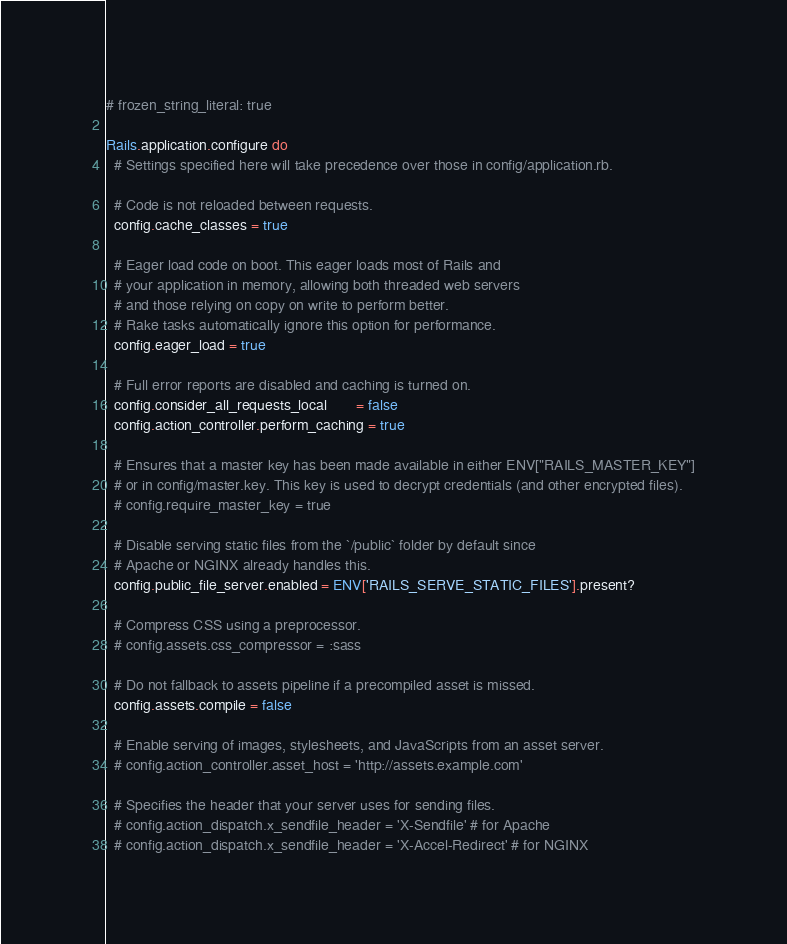<code> <loc_0><loc_0><loc_500><loc_500><_Ruby_># frozen_string_literal: true

Rails.application.configure do
  # Settings specified here will take precedence over those in config/application.rb.

  # Code is not reloaded between requests.
  config.cache_classes = true

  # Eager load code on boot. This eager loads most of Rails and
  # your application in memory, allowing both threaded web servers
  # and those relying on copy on write to perform better.
  # Rake tasks automatically ignore this option for performance.
  config.eager_load = true

  # Full error reports are disabled and caching is turned on.
  config.consider_all_requests_local       = false
  config.action_controller.perform_caching = true

  # Ensures that a master key has been made available in either ENV["RAILS_MASTER_KEY"]
  # or in config/master.key. This key is used to decrypt credentials (and other encrypted files).
  # config.require_master_key = true

  # Disable serving static files from the `/public` folder by default since
  # Apache or NGINX already handles this.
  config.public_file_server.enabled = ENV['RAILS_SERVE_STATIC_FILES'].present?

  # Compress CSS using a preprocessor.
  # config.assets.css_compressor = :sass

  # Do not fallback to assets pipeline if a precompiled asset is missed.
  config.assets.compile = false

  # Enable serving of images, stylesheets, and JavaScripts from an asset server.
  # config.action_controller.asset_host = 'http://assets.example.com'

  # Specifies the header that your server uses for sending files.
  # config.action_dispatch.x_sendfile_header = 'X-Sendfile' # for Apache
  # config.action_dispatch.x_sendfile_header = 'X-Accel-Redirect' # for NGINX
</code> 